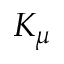<formula> <loc_0><loc_0><loc_500><loc_500>K _ { \mu }</formula> 